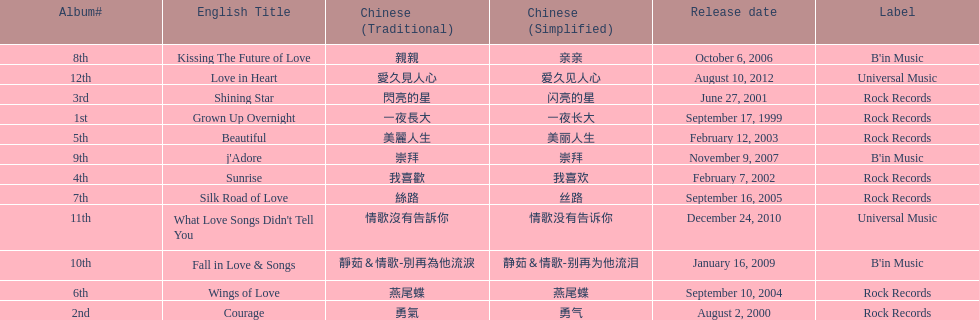What is the number of songs on rock records? 7. 